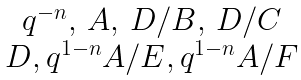Convert formula to latex. <formula><loc_0><loc_0><loc_500><loc_500>\begin{matrix} q ^ { - n } , \, A , \, D / B , \, D / C \\ D , q ^ { 1 - n } A / E , q ^ { 1 - n } A / F \end{matrix}</formula> 